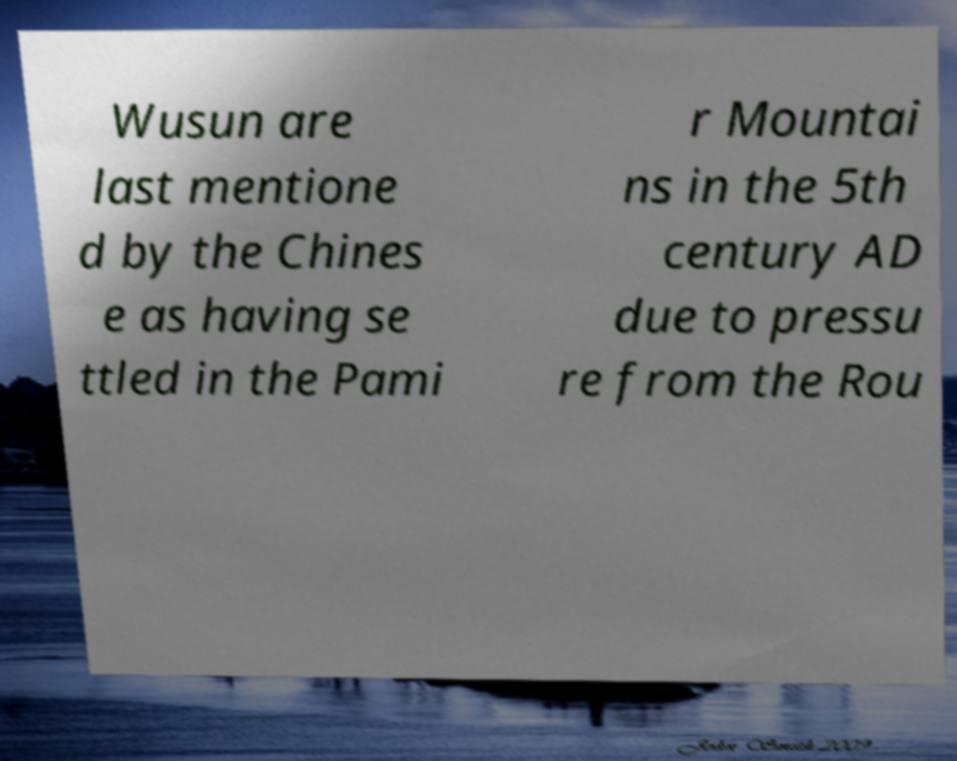Could you extract and type out the text from this image? Wusun are last mentione d by the Chines e as having se ttled in the Pami r Mountai ns in the 5th century AD due to pressu re from the Rou 